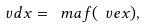<formula> <loc_0><loc_0><loc_500><loc_500>\ v d { x } = \ m a { f } ( \ v e { x } ) ,</formula> 